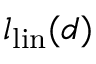<formula> <loc_0><loc_0><loc_500><loc_500>l _ { l i n } ( d )</formula> 